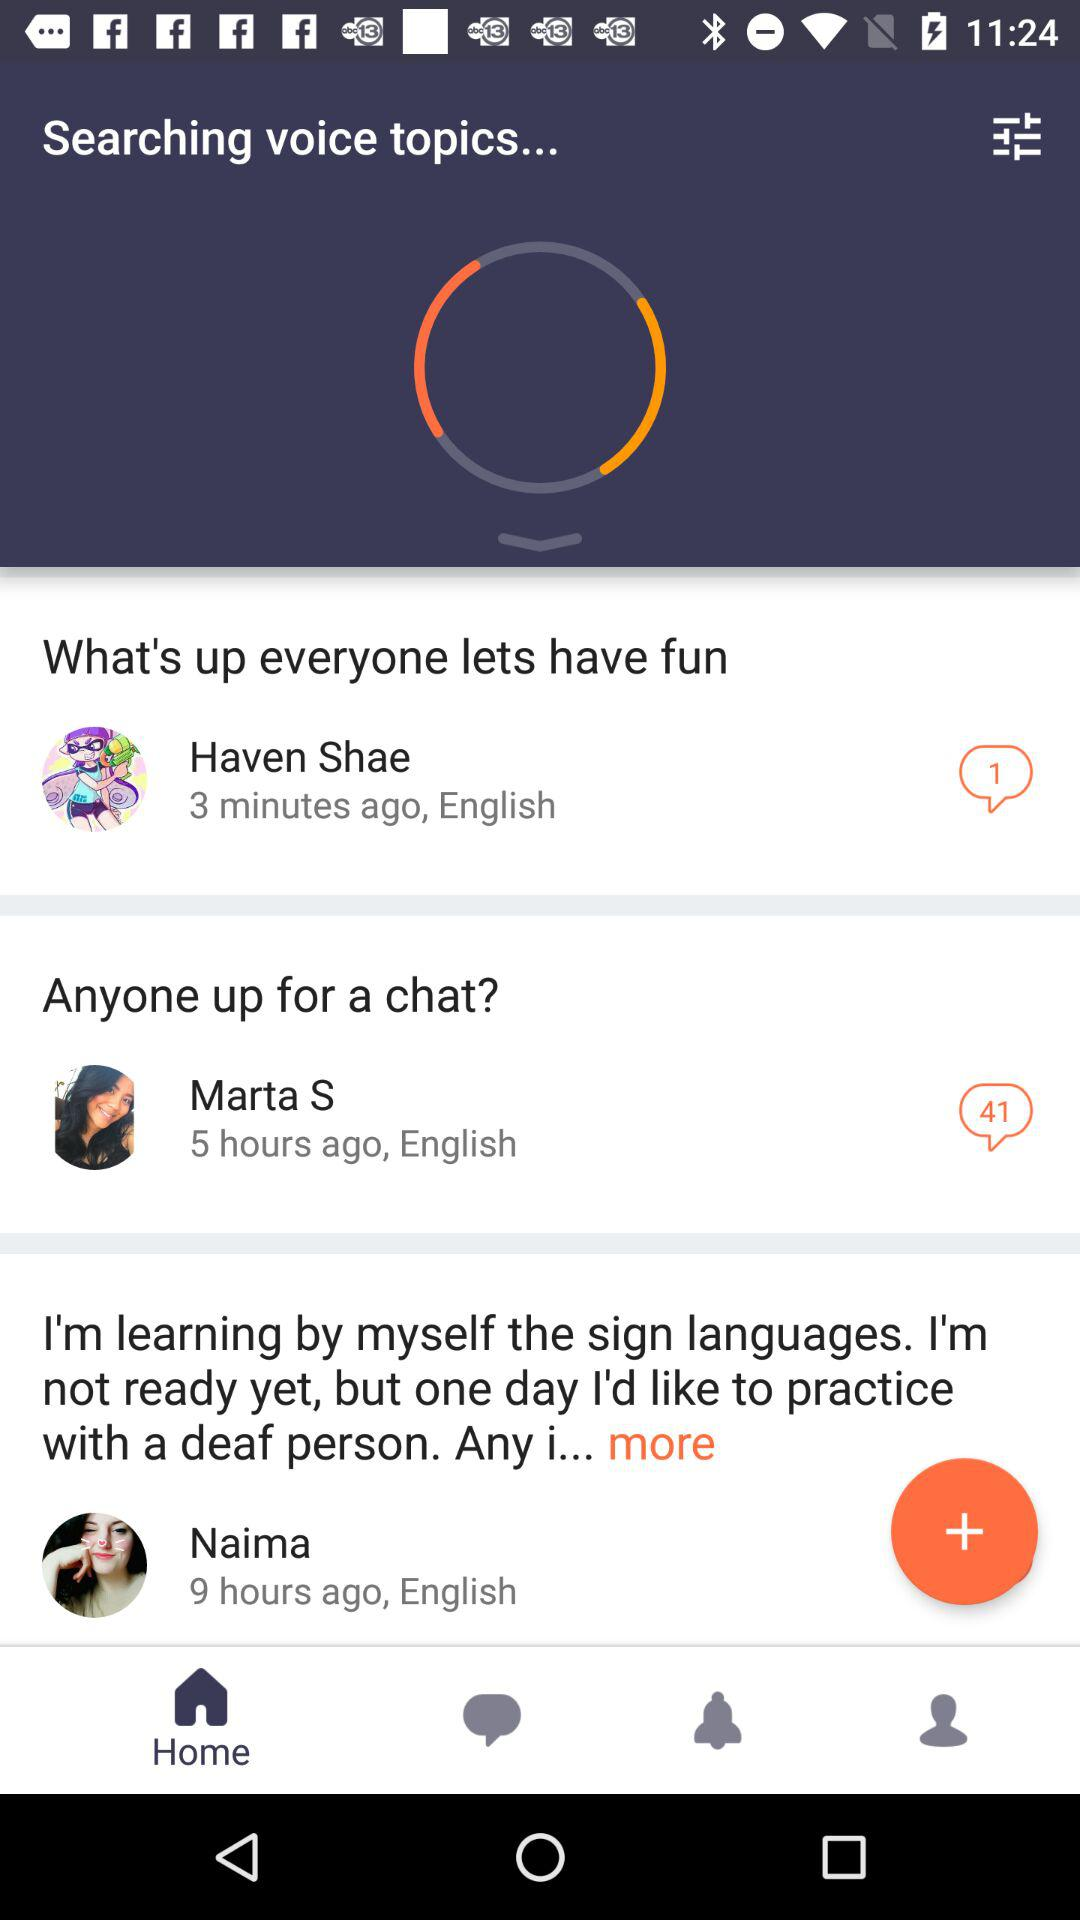How many people are in this conversation?
Answer the question using a single word or phrase. 3 